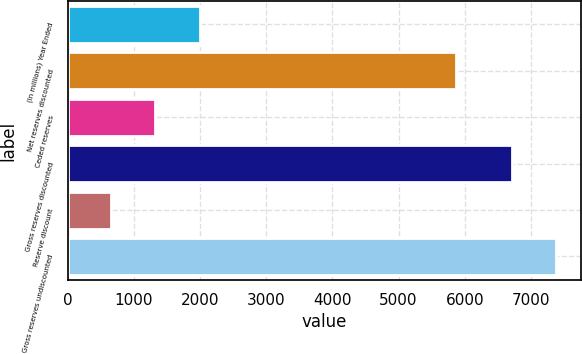Convert chart to OTSL. <chart><loc_0><loc_0><loc_500><loc_500><bar_chart><fcel>(In millions) Year Ended<fcel>Net reserves discounted<fcel>Ceded reserves<fcel>Gross reserves discounted<fcel>Reserve discount<fcel>Gross reserves undiscounted<nl><fcel>2005<fcel>5867<fcel>1325.2<fcel>6712<fcel>654<fcel>7383.2<nl></chart> 